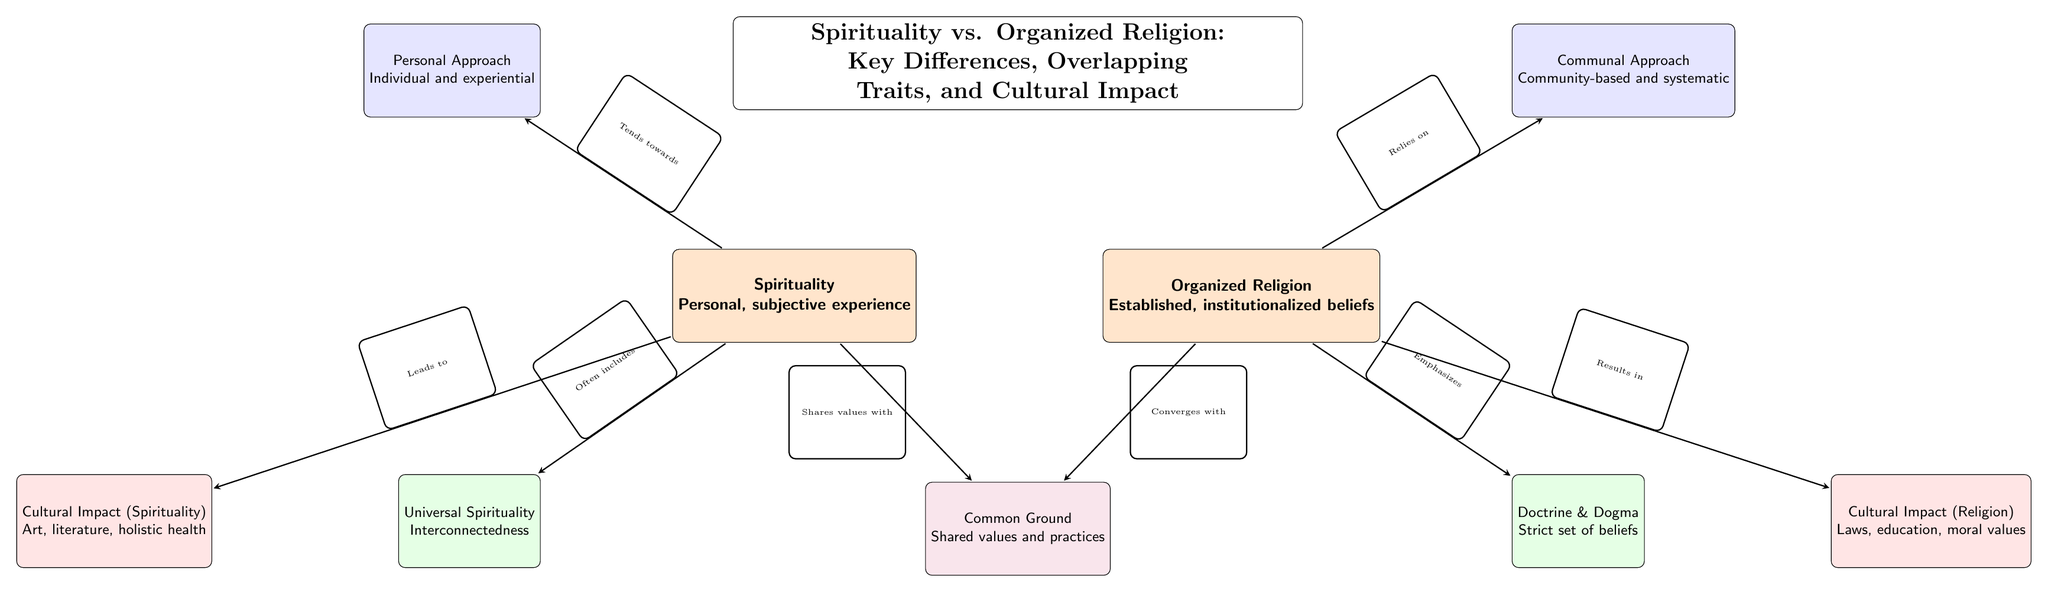What are the two main categories illustrated in the diagram? The diagram clearly identifies two main categories: Spirituality and Organized Religion, each labeled prominently at the top of their respective sections.
Answer: Spirituality and Organized Religion How many secondary nodes are present in the diagram? The diagram includes four secondary nodes, which are Personal Approach, Communal Approach, Universal Spirituality, and Doctrine & Dogma, as indicated in the structure.
Answer: 4 What type of cultural impact does spirituality lead to according to the diagram? The diagram specifies that spirituality leads to a cultural impact that encompasses areas such as art, literature, and holistic health, as depicted in the impact node associated with spirituality.
Answer: Art, literature, holistic health Which approach is associated with organized religion? The diagram indicates that organized religion relies on a communal approach, which is shown in the secondary node linked to organized religion.
Answer: Communal Approach What shared aspect do spirituality and organized religion converge upon? The diagram establishes that both spirituality and organized religion share common values and practices, illustrated in the common ground node situated between the two main categories.
Answer: Shared values and practices How does spirituality view interconnectedness? According to the diagram, spirituality emphasizes the concept of universal spirituality, indicating an understanding of interconnectedness among individuals, which is depicted in the corresponding tertiary node.
Answer: Interconnectedness Which cultural impacts are associated with organized religion as illustrated? The diagram reflects that organized religion results in cultural impacts related to laws, education, and moral values, shown in the impact node for organized religion.
Answer: Laws, education, moral values What is the relationship between spirituality and the personal approach? The diagram illustrates that spirituality tends towards a personal approach, suggesting that it focuses on individual and experiential dimensions, as indicated by the directed connection in the diagram.
Answer: Tends towards What is emphasized by organized religion in contrast to spirituality? The diagram emphasizes that organized religion stresses doctrine and dogma, which establishes a strict set of beliefs that differ from the more flexible nature of spirituality.
Answer: Doctrine & Dogma 